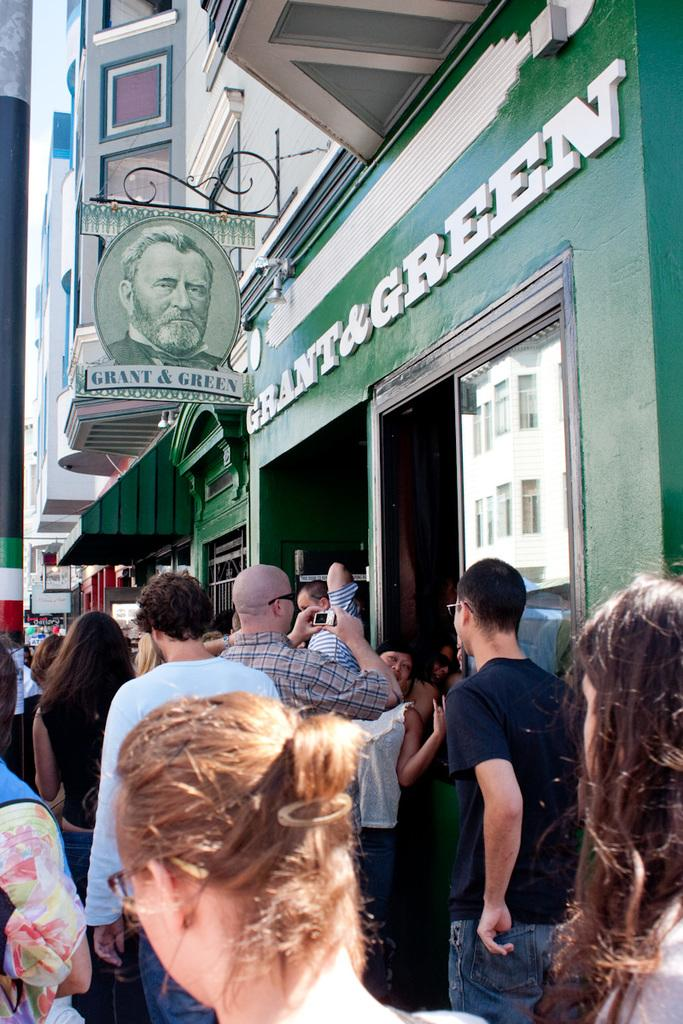What type of establishment is depicted in the image? There is a store in the image. What is located above the store? There is a building above the store. How many people are standing outside the store? There are many people standing outside the store. What can be seen on the left side of the image? There is a pole on the left side of the image. What type of bomb can be seen exploding near the store in the image? There is no bomb or destruction present in the image; it shows a store with people standing outside and a pole on the left side. 